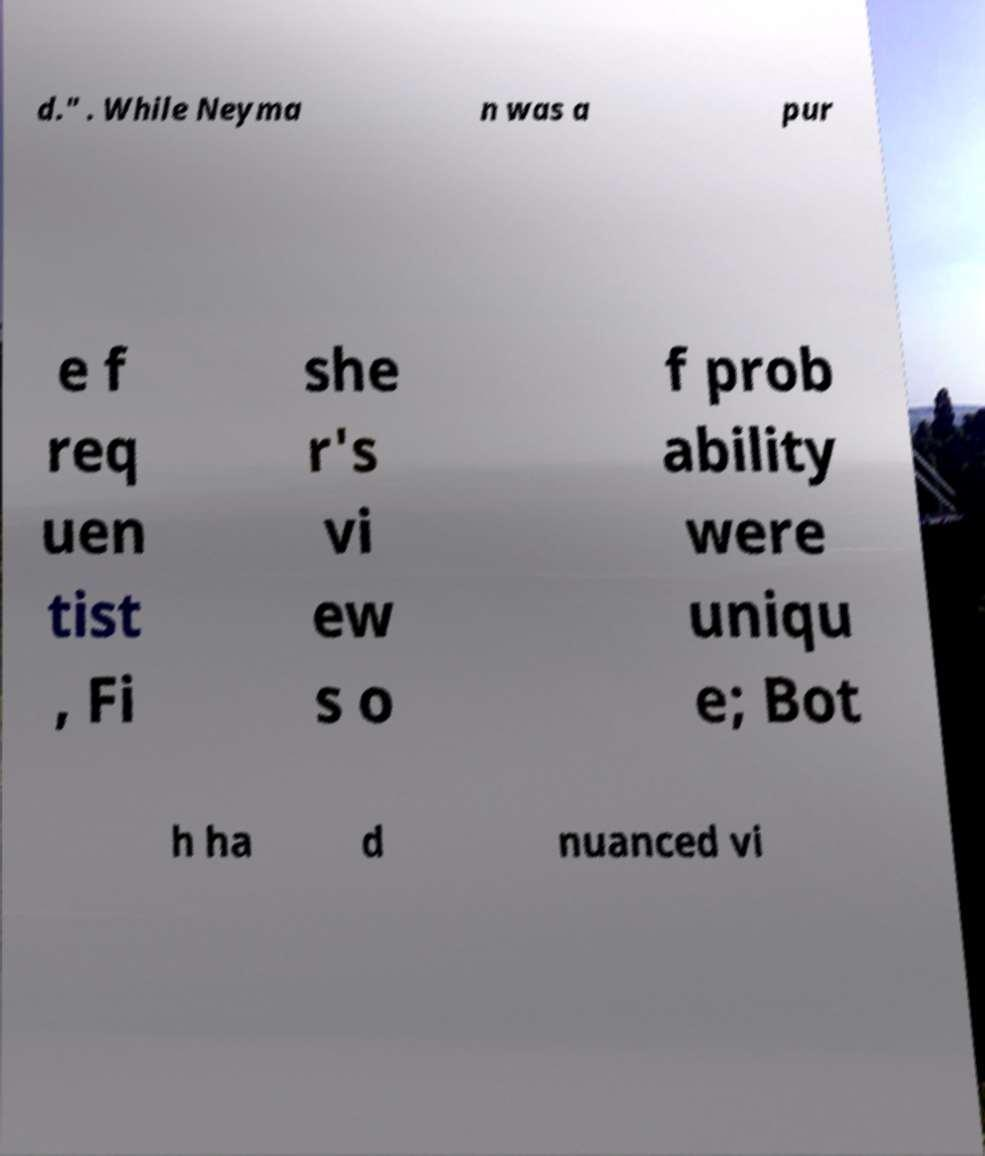Could you extract and type out the text from this image? d." . While Neyma n was a pur e f req uen tist , Fi she r's vi ew s o f prob ability were uniqu e; Bot h ha d nuanced vi 